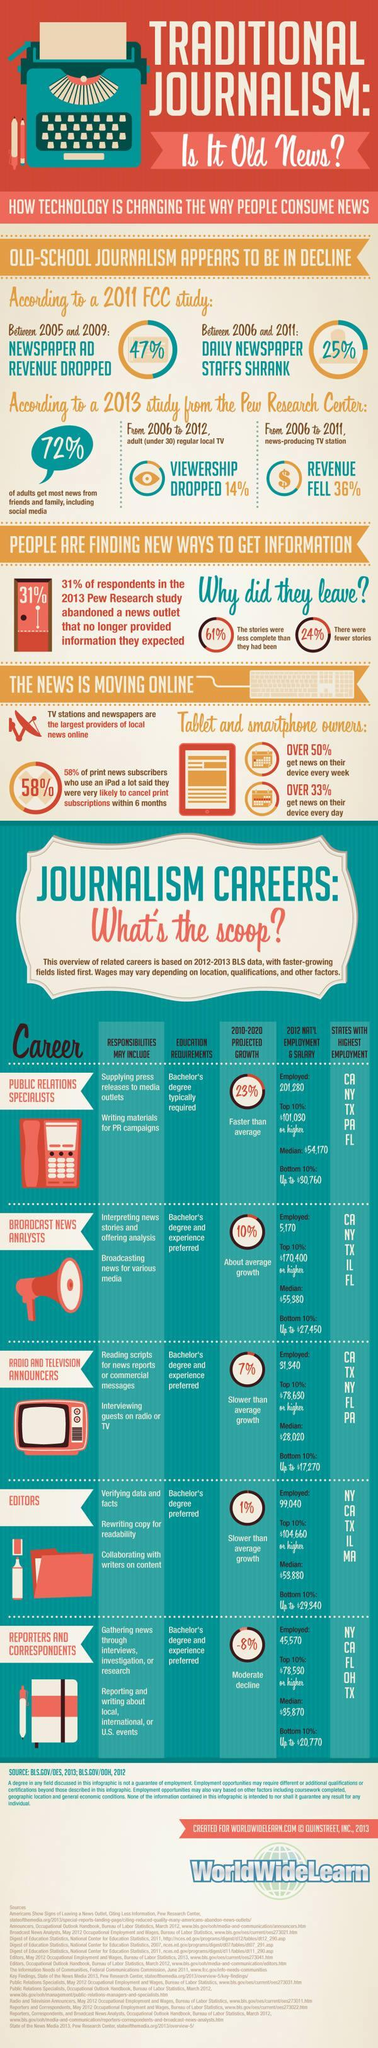Which state tops in recruitment of editors, reporters and correspondents, Texas, California, or New York?
Answer the question with a short phrase. New York Which career has the second highest project average growth? Broadcast News Analyst 